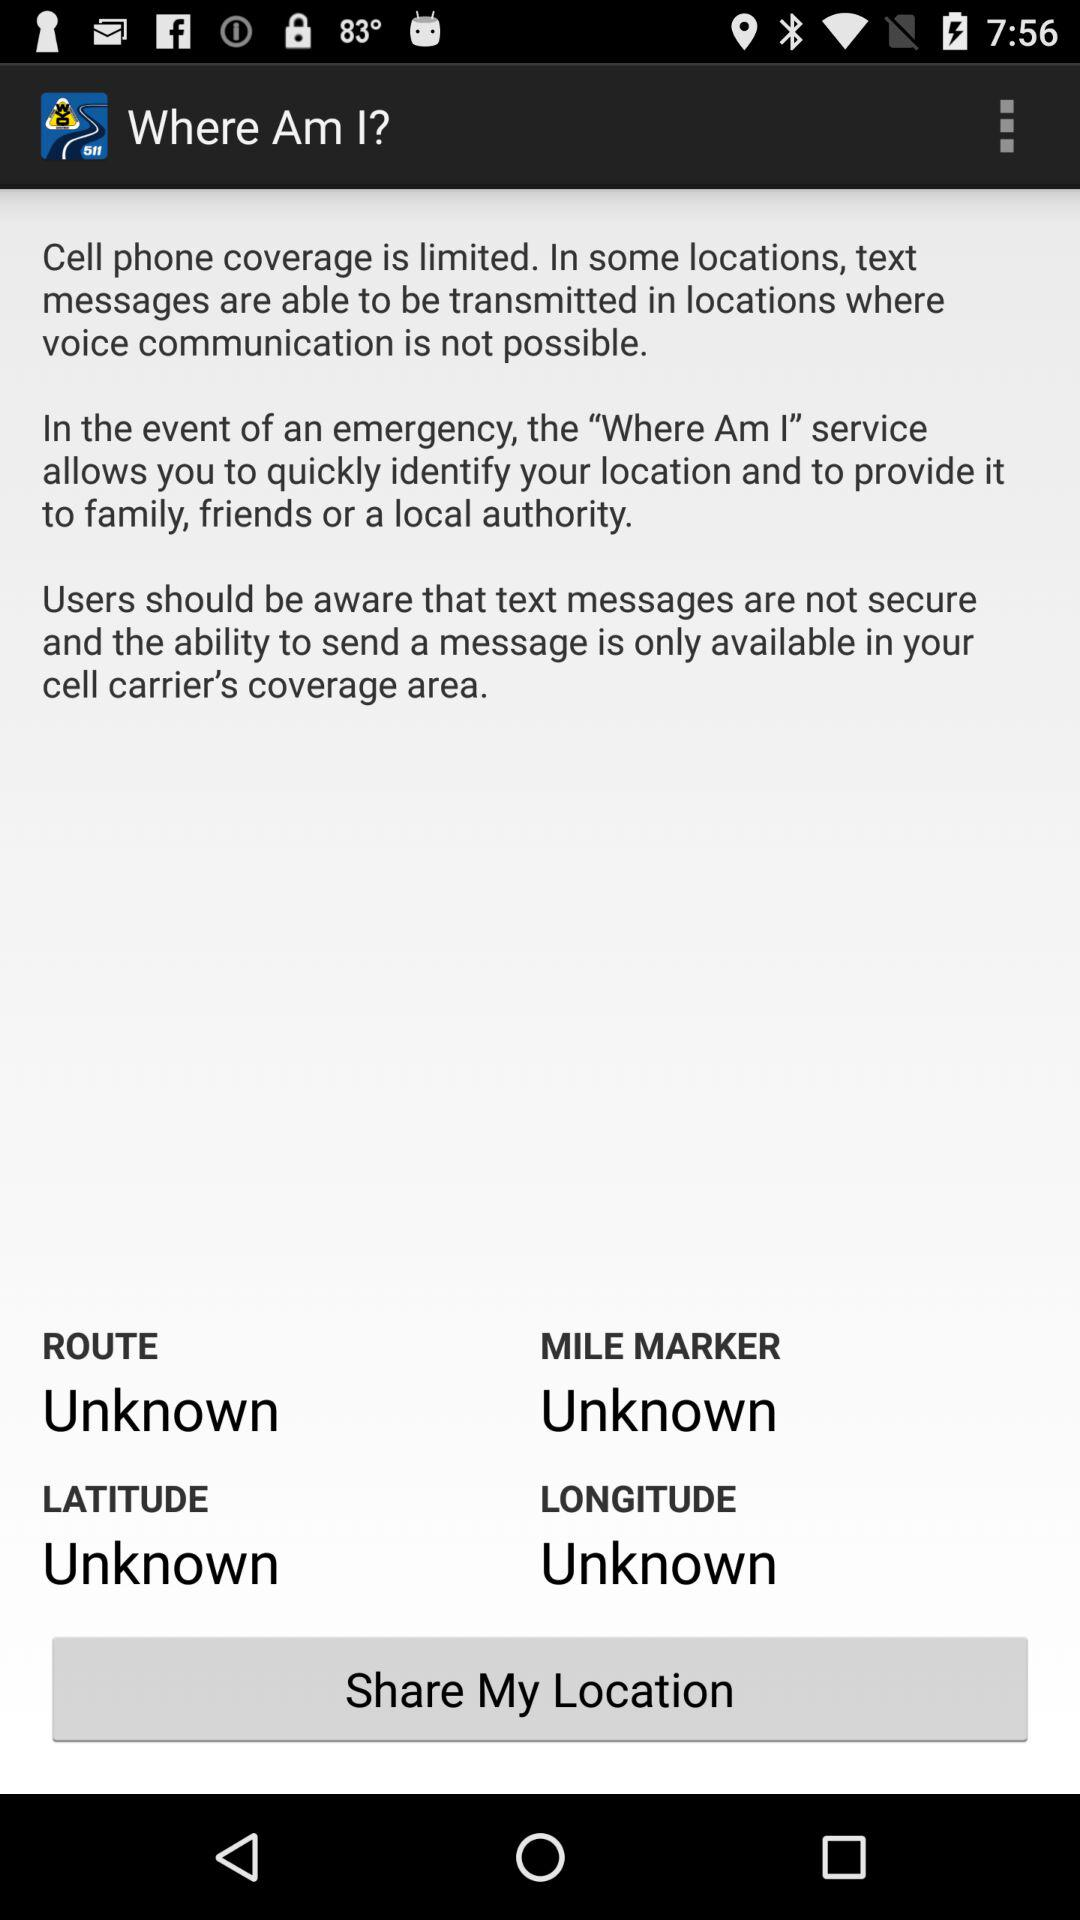What is the longitude? The longitude is "Unknown". 